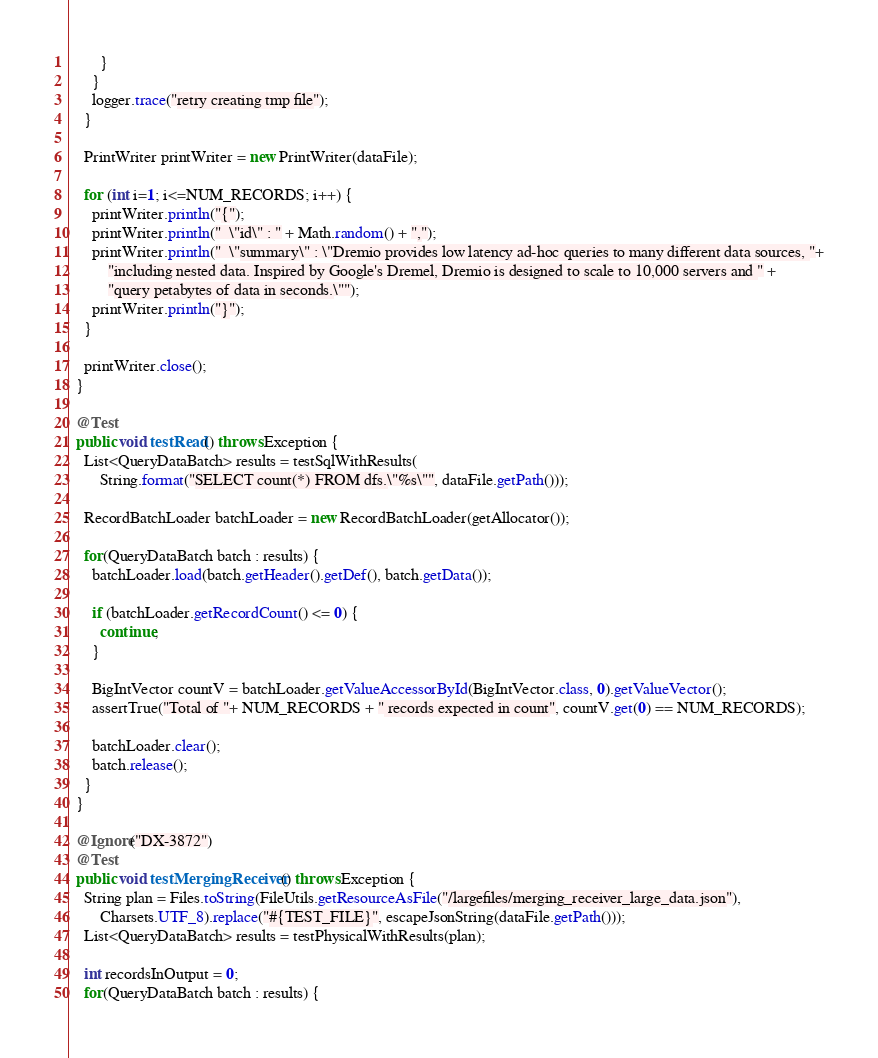<code> <loc_0><loc_0><loc_500><loc_500><_Java_>        }
      }
      logger.trace("retry creating tmp file");
    }

    PrintWriter printWriter = new PrintWriter(dataFile);

    for (int i=1; i<=NUM_RECORDS; i++) {
      printWriter.println("{");
      printWriter.println("  \"id\" : " + Math.random() + ",");
      printWriter.println("  \"summary\" : \"Dremio provides low latency ad-hoc queries to many different data sources, "+
          "including nested data. Inspired by Google's Dremel, Dremio is designed to scale to 10,000 servers and " +
          "query petabytes of data in seconds.\"");
      printWriter.println("}");
    }

    printWriter.close();
  }

  @Test
  public void testRead() throws Exception {
    List<QueryDataBatch> results = testSqlWithResults(
        String.format("SELECT count(*) FROM dfs.\"%s\"", dataFile.getPath()));

    RecordBatchLoader batchLoader = new RecordBatchLoader(getAllocator());

    for(QueryDataBatch batch : results) {
      batchLoader.load(batch.getHeader().getDef(), batch.getData());

      if (batchLoader.getRecordCount() <= 0) {
        continue;
      }

      BigIntVector countV = batchLoader.getValueAccessorById(BigIntVector.class, 0).getValueVector();
      assertTrue("Total of "+ NUM_RECORDS + " records expected in count", countV.get(0) == NUM_RECORDS);

      batchLoader.clear();
      batch.release();
    }
  }

  @Ignore("DX-3872")
  @Test
  public void testMergingReceiver() throws Exception {
    String plan = Files.toString(FileUtils.getResourceAsFile("/largefiles/merging_receiver_large_data.json"),
        Charsets.UTF_8).replace("#{TEST_FILE}", escapeJsonString(dataFile.getPath()));
    List<QueryDataBatch> results = testPhysicalWithResults(plan);

    int recordsInOutput = 0;
    for(QueryDataBatch batch : results) {</code> 